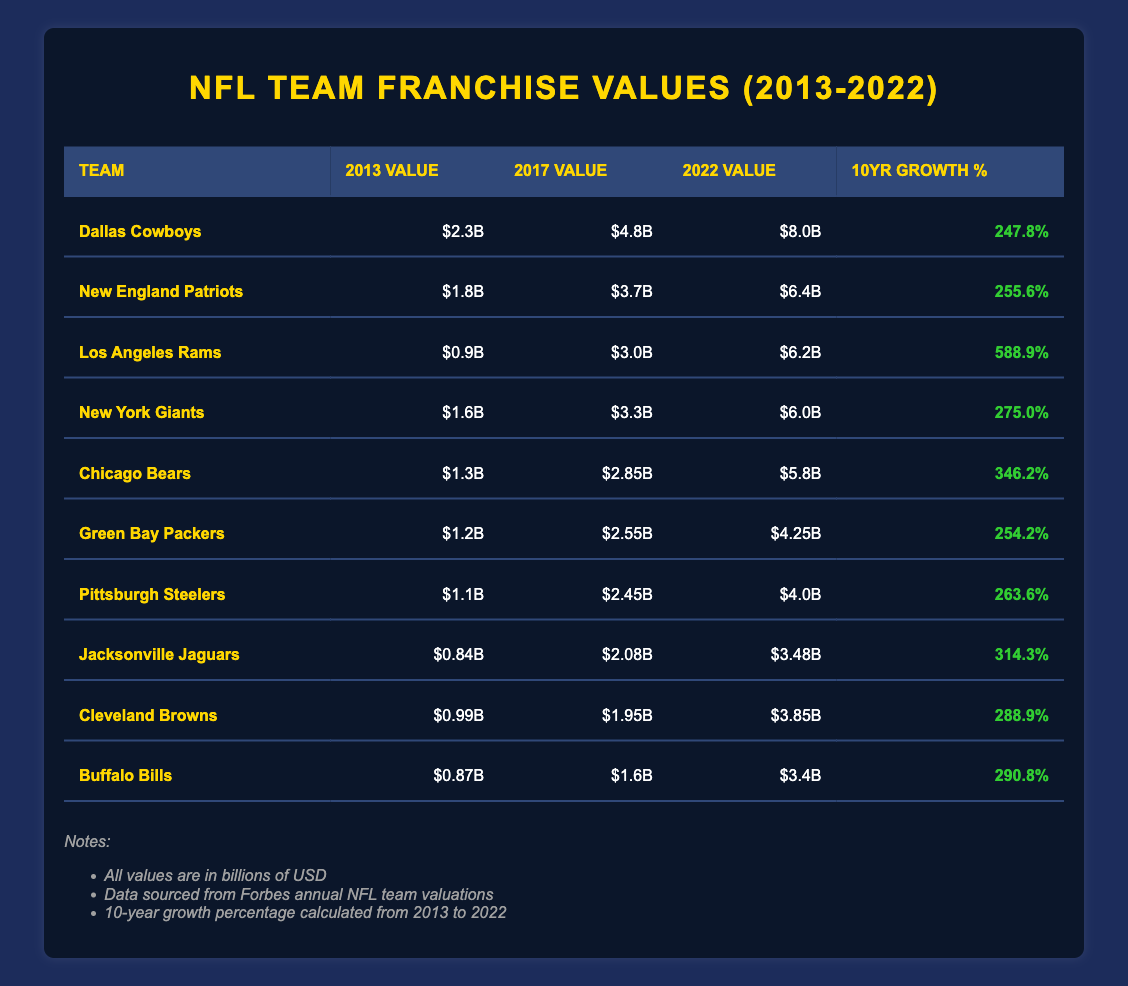What was the 2022 value of the Dallas Cowboys? Referring to the table, the 2022 value for the Dallas Cowboys is listed as $8.0 billion.
Answer: $8.0 billion Which NFL team had the highest growth percentage over the 10 years? Looking at the 10-year growth percentage column, the Los Angeles Rams have the highest growth percentage of 588.9%.
Answer: Los Angeles Rams What is the average 2022 value of the teams listed in the table? To find the average, sum the 2022 values: $8.0B + $6.4B + $6.2B + $6.0B + $5.8B + $4.25B + $4.0B + $3.48B + $3.85B + $3.4B = $57.6 billion. There are 10 teams, so the average is $57.6 billion / 10 = $5.76 billion.
Answer: $5.76 billion Did the Chicago Bears have a greater 2013 value than the Green Bay Packers? The 2013 value for the Chicago Bears is $1.3 billion, and for the Green Bay Packers, it is $1.2 billion. Since $1.3 billion is greater than $1.2 billion, the answer is yes.
Answer: Yes What was the difference in value between the New England Patriots in 2013 and the Los Angeles Rams in 2022? The Patriots had a value of $1.8 billion in 2013, while the Rams had a value of $6.2 billion in 2022. The difference is $6.2 billion - $1.8 billion = $4.4 billion.
Answer: $4.4 billion Which team had a 10-year growth percentage lower than 300%? Looking through the 10-year growth percentage column, both the Jacksonville Jaguars (314.3%) and the Cleveland Browns (288.9%) fall within this category. The Cleveland Browns had a growth percentage lower than 300%.
Answer: Cleveland Browns What was the 2017 value of the team with the highest 10-year growth percentage? The team with the highest 10-year growth percentage is the Los Angeles Rams, which had a 2017 value of $3.0 billion.
Answer: $3.0 billion Are the 2022 values for the New York Giants and the Pittsburgh Steelers the same? The 2022 value for the New York Giants is $6.0 billion, while for the Pittsburgh Steelers, it is $4.0 billion. Since these amounts are not equal, the answer is no.
Answer: No 